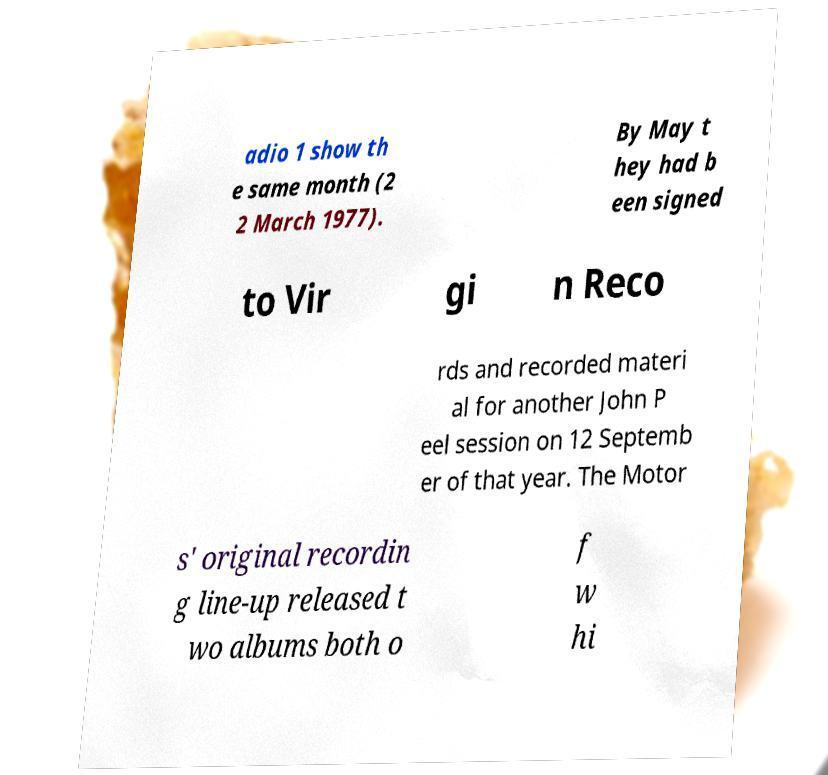Can you accurately transcribe the text from the provided image for me? adio 1 show th e same month (2 2 March 1977). By May t hey had b een signed to Vir gi n Reco rds and recorded materi al for another John P eel session on 12 Septemb er of that year. The Motor s' original recordin g line-up released t wo albums both o f w hi 